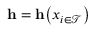Convert formula to latex. <formula><loc_0><loc_0><loc_500><loc_500>h = h \left ( { x } _ { i \in \mathcal { T } } \right )</formula> 